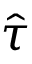Convert formula to latex. <formula><loc_0><loc_0><loc_500><loc_500>\hat { \tau }</formula> 